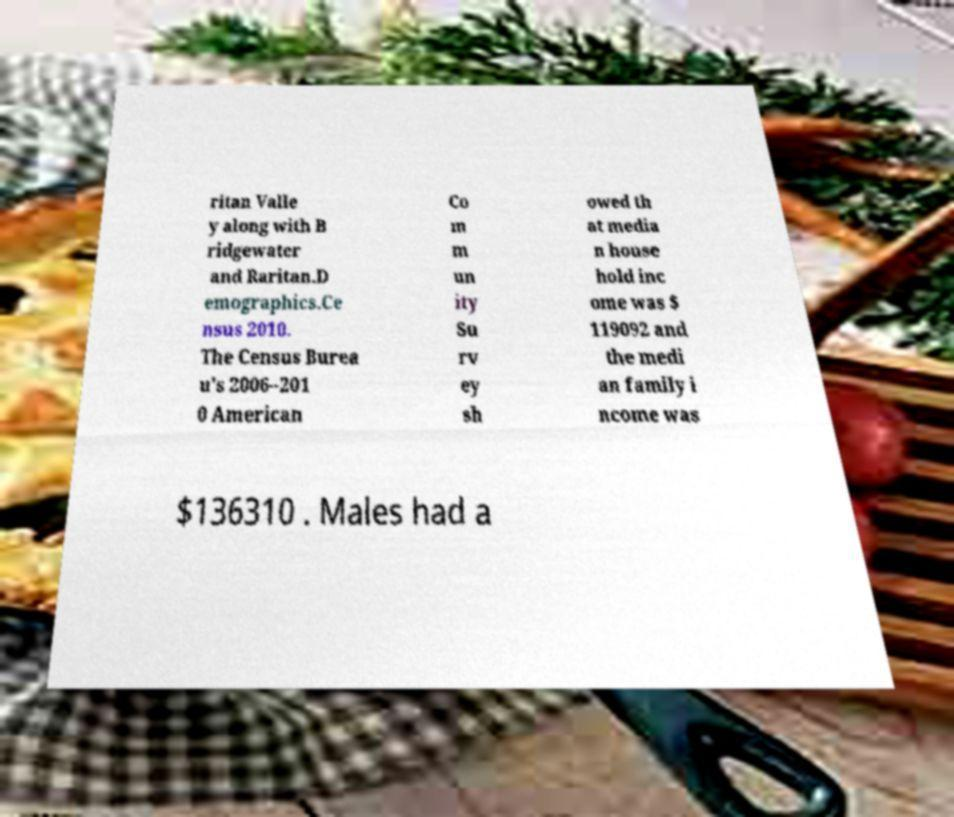Please read and relay the text visible in this image. What does it say? ritan Valle y along with B ridgewater and Raritan.D emographics.Ce nsus 2010. The Census Burea u's 2006–201 0 American Co m m un ity Su rv ey sh owed th at media n house hold inc ome was $ 119092 and the medi an family i ncome was $136310 . Males had a 